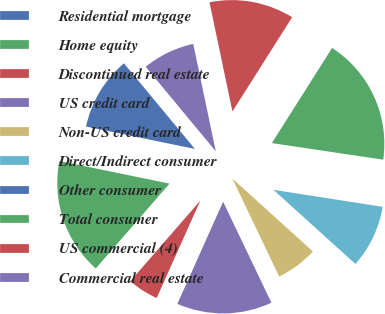Convert chart to OTSL. <chart><loc_0><loc_0><loc_500><loc_500><pie_chart><fcel>Residential mortgage<fcel>Home equity<fcel>Discontinued real estate<fcel>US credit card<fcel>Non-US credit card<fcel>Direct/Indirect consumer<fcel>Other consumer<fcel>Total consumer<fcel>US commercial (4)<fcel>Commercial real estate<nl><fcel>10.76%<fcel>16.84%<fcel>4.68%<fcel>13.8%<fcel>6.2%<fcel>9.24%<fcel>0.11%<fcel>18.37%<fcel>12.28%<fcel>7.72%<nl></chart> 